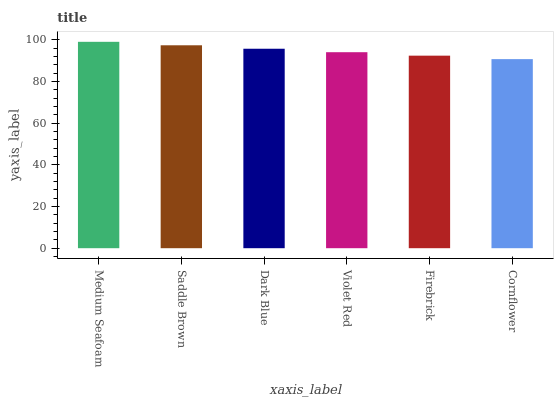Is Cornflower the minimum?
Answer yes or no. Yes. Is Medium Seafoam the maximum?
Answer yes or no. Yes. Is Saddle Brown the minimum?
Answer yes or no. No. Is Saddle Brown the maximum?
Answer yes or no. No. Is Medium Seafoam greater than Saddle Brown?
Answer yes or no. Yes. Is Saddle Brown less than Medium Seafoam?
Answer yes or no. Yes. Is Saddle Brown greater than Medium Seafoam?
Answer yes or no. No. Is Medium Seafoam less than Saddle Brown?
Answer yes or no. No. Is Dark Blue the high median?
Answer yes or no. Yes. Is Violet Red the low median?
Answer yes or no. Yes. Is Medium Seafoam the high median?
Answer yes or no. No. Is Saddle Brown the low median?
Answer yes or no. No. 